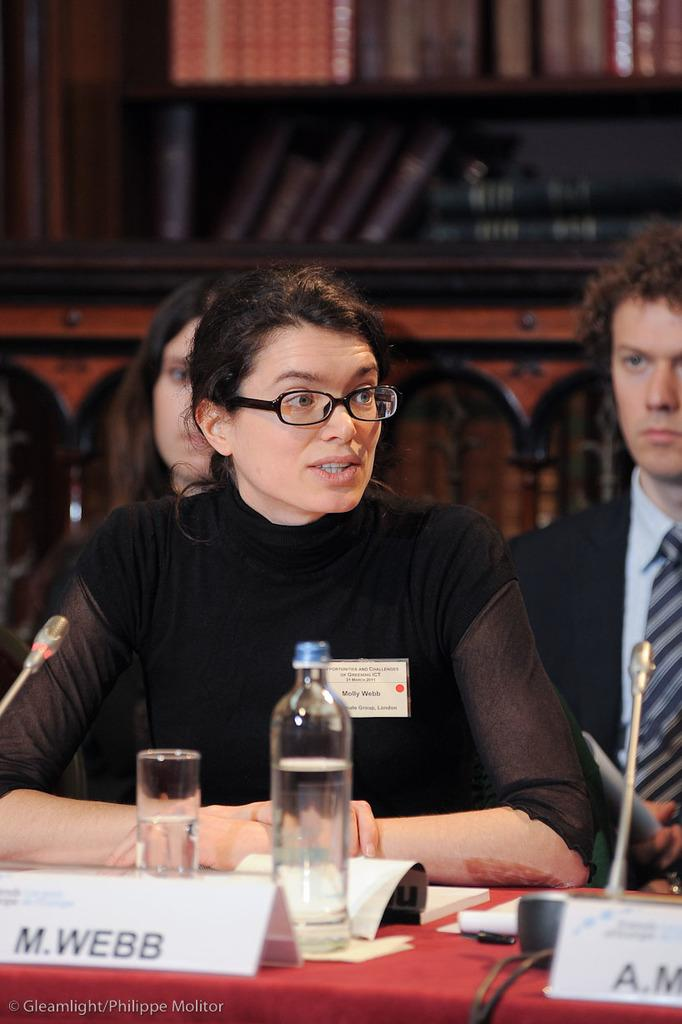What are the persons in the image doing? The persons in the image are sitting on chairs. What is present on the table in the image? There is a bottle, a glass, and a book on the table. What is visible in the background of the image? There is a rack visible in the background of the image. What type of cactus is present on the table in the image? There is no cactus present on the table in the image. What is the persons smoking from in the image? There is no smoking activity or pipe visible in the image. 